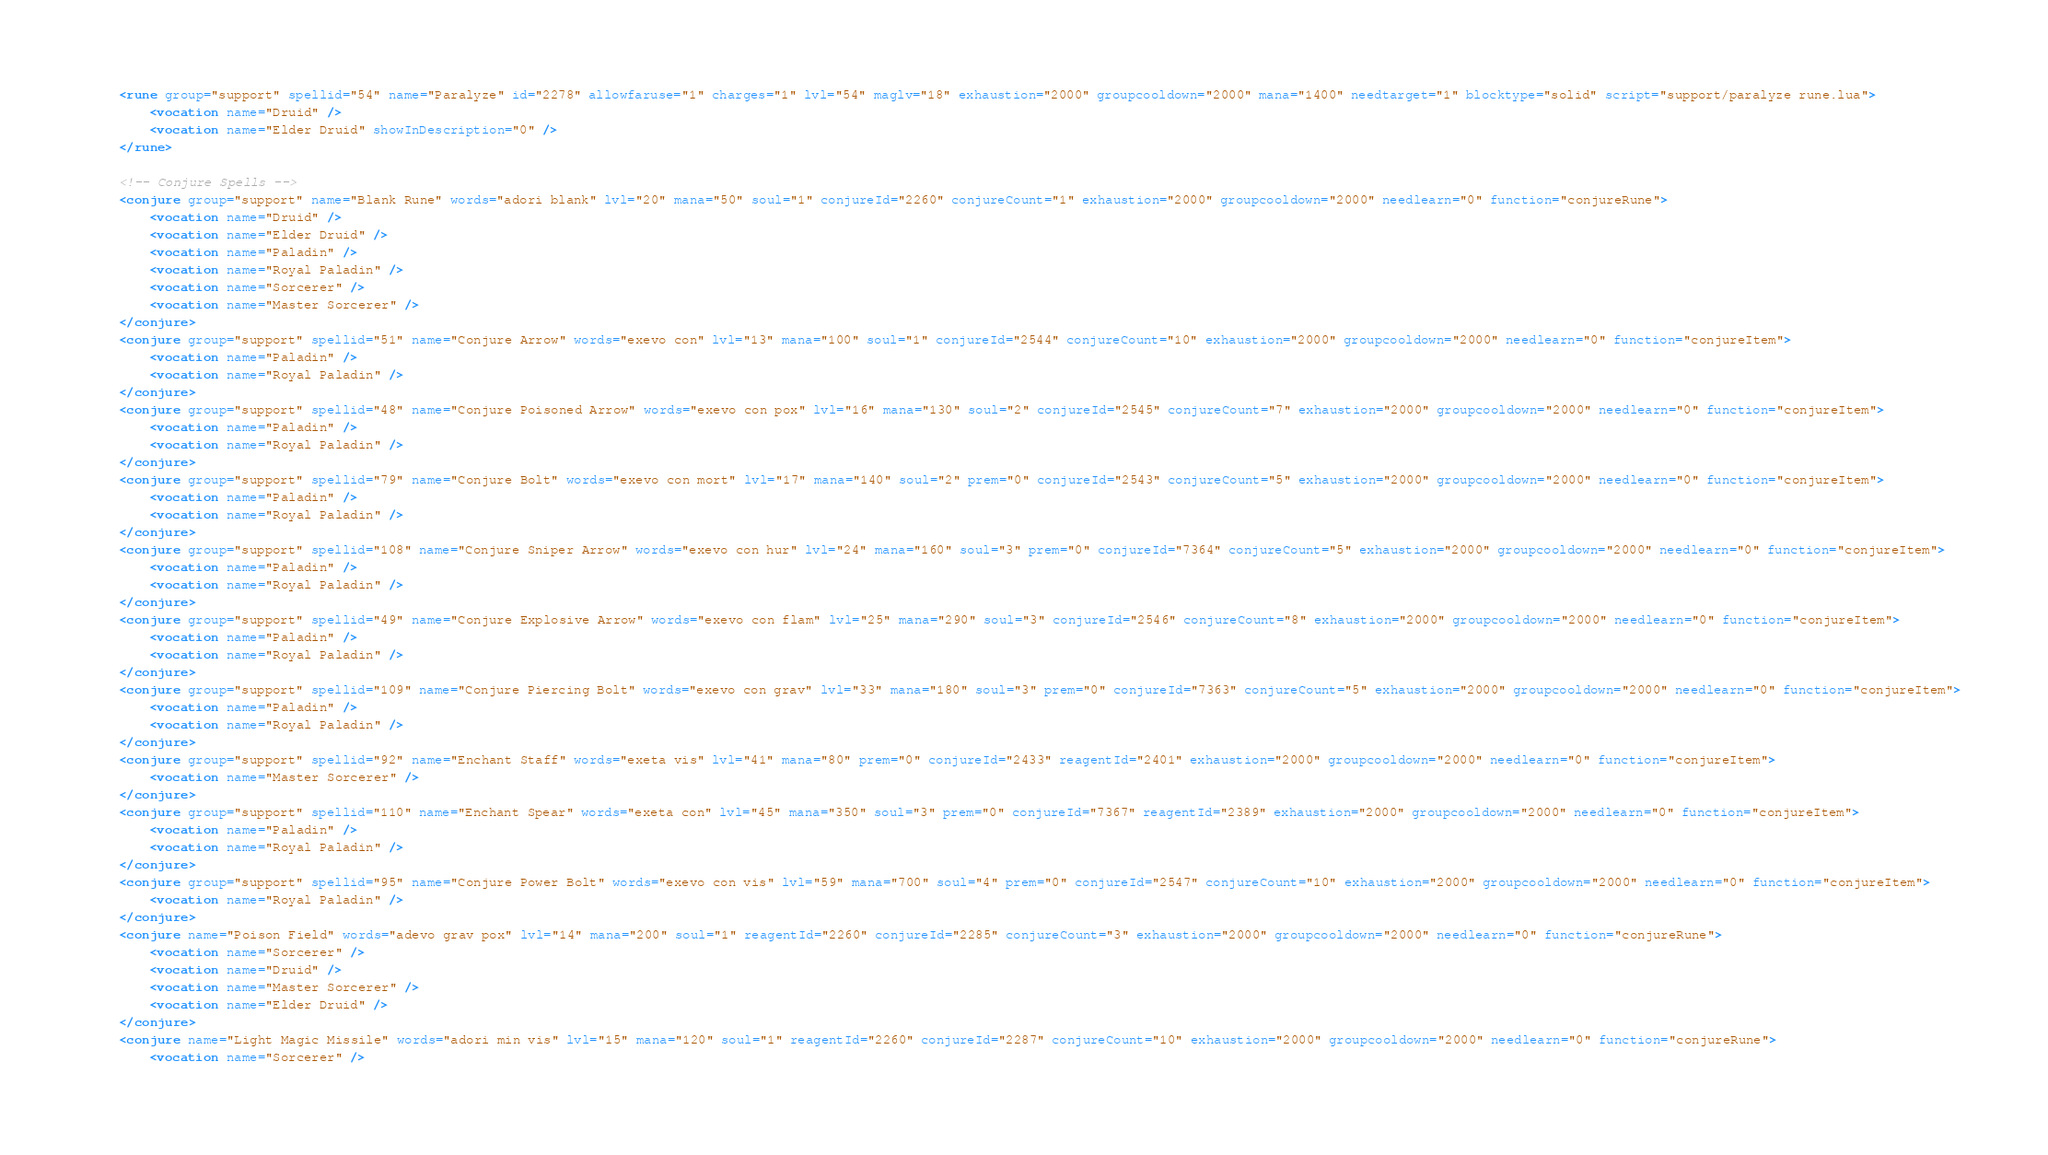Convert code to text. <code><loc_0><loc_0><loc_500><loc_500><_XML_>	<rune group="support" spellid="54" name="Paralyze" id="2278" allowfaruse="1" charges="1" lvl="54" maglv="18" exhaustion="2000" groupcooldown="2000" mana="1400" needtarget="1" blocktype="solid" script="support/paralyze rune.lua">
		<vocation name="Druid" />
		<vocation name="Elder Druid" showInDescription="0" />
	</rune>

	<!-- Conjure Spells -->
	<conjure group="support" name="Blank Rune" words="adori blank" lvl="20" mana="50" soul="1" conjureId="2260" conjureCount="1" exhaustion="2000" groupcooldown="2000" needlearn="0" function="conjureRune">
		<vocation name="Druid" />
		<vocation name="Elder Druid" />
		<vocation name="Paladin" />
		<vocation name="Royal Paladin" />
		<vocation name="Sorcerer" />
		<vocation name="Master Sorcerer" />
	</conjure>
	<conjure group="support" spellid="51" name="Conjure Arrow" words="exevo con" lvl="13" mana="100" soul="1" conjureId="2544" conjureCount="10" exhaustion="2000" groupcooldown="2000" needlearn="0" function="conjureItem">
		<vocation name="Paladin" />
		<vocation name="Royal Paladin" />
	</conjure>
	<conjure group="support" spellid="48" name="Conjure Poisoned Arrow" words="exevo con pox" lvl="16" mana="130" soul="2" conjureId="2545" conjureCount="7" exhaustion="2000" groupcooldown="2000" needlearn="0" function="conjureItem">
		<vocation name="Paladin" />
		<vocation name="Royal Paladin" />
	</conjure>
	<conjure group="support" spellid="79" name="Conjure Bolt" words="exevo con mort" lvl="17" mana="140" soul="2" prem="0" conjureId="2543" conjureCount="5" exhaustion="2000" groupcooldown="2000" needlearn="0" function="conjureItem">
		<vocation name="Paladin" />
		<vocation name="Royal Paladin" />
	</conjure>
	<conjure group="support" spellid="108" name="Conjure Sniper Arrow" words="exevo con hur" lvl="24" mana="160" soul="3" prem="0" conjureId="7364" conjureCount="5" exhaustion="2000" groupcooldown="2000" needlearn="0" function="conjureItem">
		<vocation name="Paladin" />
		<vocation name="Royal Paladin" />
	</conjure>
	<conjure group="support" spellid="49" name="Conjure Explosive Arrow" words="exevo con flam" lvl="25" mana="290" soul="3" conjureId="2546" conjureCount="8" exhaustion="2000" groupcooldown="2000" needlearn="0" function="conjureItem">
		<vocation name="Paladin" />
		<vocation name="Royal Paladin" />
	</conjure>
	<conjure group="support" spellid="109" name="Conjure Piercing Bolt" words="exevo con grav" lvl="33" mana="180" soul="3" prem="0" conjureId="7363" conjureCount="5" exhaustion="2000" groupcooldown="2000" needlearn="0" function="conjureItem">
		<vocation name="Paladin" />
		<vocation name="Royal Paladin" />
	</conjure>
	<conjure group="support" spellid="92" name="Enchant Staff" words="exeta vis" lvl="41" mana="80" prem="0" conjureId="2433" reagentId="2401" exhaustion="2000" groupcooldown="2000" needlearn="0" function="conjureItem">
		<vocation name="Master Sorcerer" />
	</conjure>
	<conjure group="support" spellid="110" name="Enchant Spear" words="exeta con" lvl="45" mana="350" soul="3" prem="0" conjureId="7367" reagentId="2389" exhaustion="2000" groupcooldown="2000" needlearn="0" function="conjureItem">
		<vocation name="Paladin" />
		<vocation name="Royal Paladin" />
	</conjure>
	<conjure group="support" spellid="95" name="Conjure Power Bolt" words="exevo con vis" lvl="59" mana="700" soul="4" prem="0" conjureId="2547" conjureCount="10" exhaustion="2000" groupcooldown="2000" needlearn="0" function="conjureItem">
		<vocation name="Royal Paladin" />
	</conjure>
	<conjure name="Poison Field" words="adevo grav pox" lvl="14" mana="200" soul="1" reagentId="2260" conjureId="2285" conjureCount="3" exhaustion="2000" groupcooldown="2000" needlearn="0" function="conjureRune">
		<vocation name="Sorcerer" />
		<vocation name="Druid" />
		<vocation name="Master Sorcerer" />
		<vocation name="Elder Druid" />
	</conjure>
	<conjure name="Light Magic Missile" words="adori min vis" lvl="15" mana="120" soul="1" reagentId="2260" conjureId="2287" conjureCount="10" exhaustion="2000" groupcooldown="2000" needlearn="0" function="conjureRune">
		<vocation name="Sorcerer" /></code> 